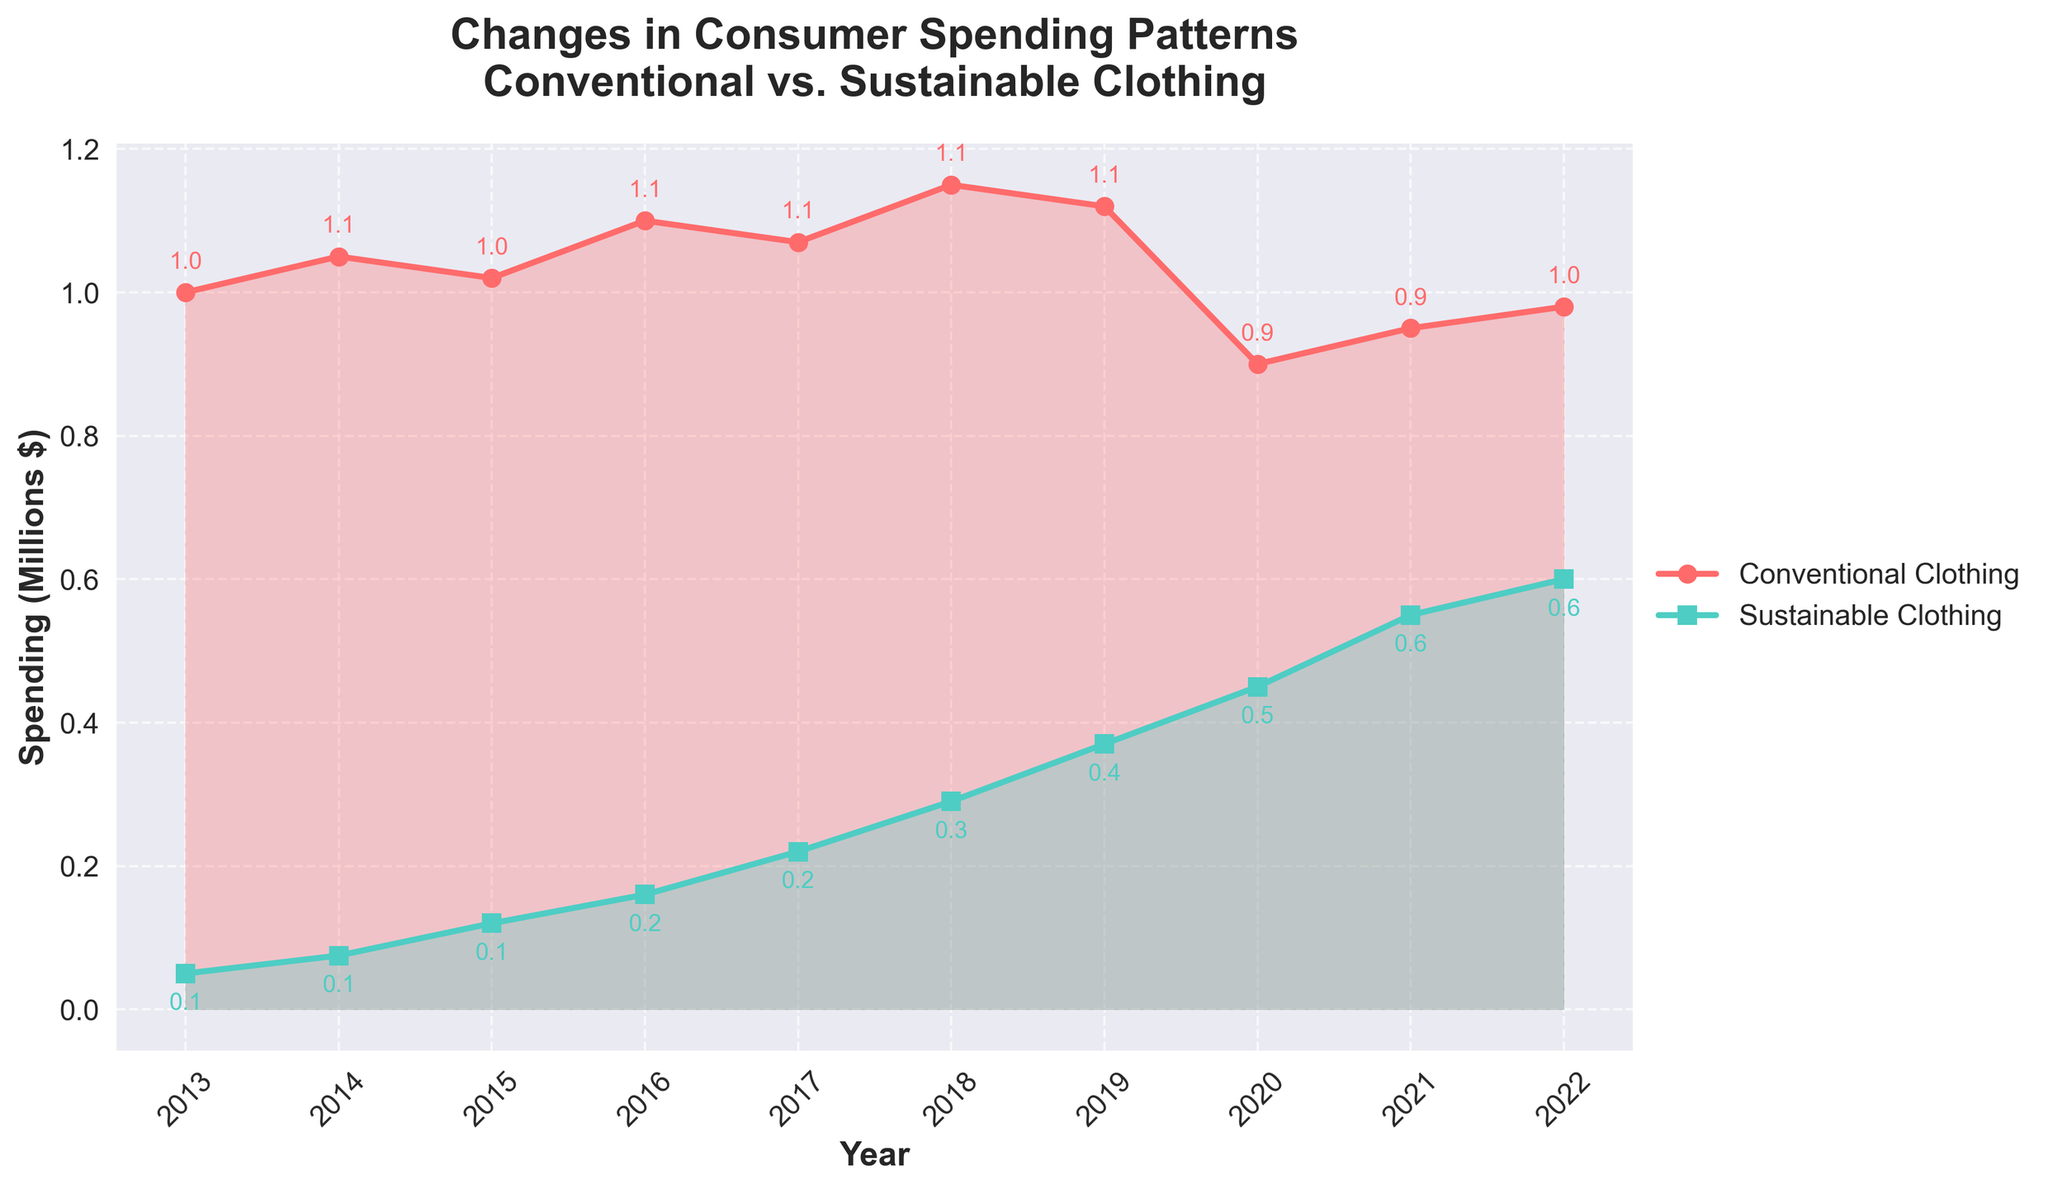What is the title of the figure? The title of the figure is displayed at the top. It reads "Changes in Consumer Spending Patterns\nConventional vs. Sustainable Clothing".
Answer: Changes in Consumer Spending Patterns\nConventional vs. Sustainable Clothing What are the spending values for conventional clothing and sustainable clothing in 2013? The plot marks spending values for each year. In 2013, the conventional clothing spending is represented by a red circle at 1.0 million dollars, and the sustainable clothing spending is shown by a green square at 0.05 million dollars.
Answer: $1,000,000 and $50,000 How did the spending on conventional clothing change from 2019 to 2020? The spending on conventional clothing in 2019 is around 1.12 million dollars, and in 2020 it drops to 0.9 million dollars. The change is a decrease of 0.22 million dollars.
Answer: Decreased by $220,000 Compare the spending on conventional clothing and sustainable clothing in 2022. In 2022, the plot shows approximately 0.98 million dollars on conventional clothing (red line) and 0.6 million dollars on sustainable clothing (green line).
Answer: Conventional: $980,000, Sustainable: $600,000 What is the total consumer spending on sustainable clothing between 2020 and 2022? To find the total, add the spending values for 2020 (0.45 million dollars), 2021 (0.55 million dollars), and 2022 (0.6 million dollars). This results in a total of 1.6 million dollars.
Answer: $1,600,000 Which year shows the highest spending on conventional clothing and what value is it? The plot shows the highest point in the time series for conventional clothing spend is in 2018 at approximately 1.15 million dollars.
Answer: 2018, $1,150,000 Did sustainable clothing spending ever exceed conventional clothing spending over the last 10 years? Observing the plot, there is no point where the green line (sustainable) exceeds the red line (conventional).
Answer: No Which year experienced the greatest increase in sustainable clothing spending compared to the previous year, and what was the amount of the increase? The largest increase is observed from 2016 to 2017, where spending went from 0.16 million dollars to 0.22 million dollars, showing an increase of 0.06 million dollars.
Answer: 2017, $60,000 What can we infer about consumer trends from 2020 to 2022 with regard to conventional vs. sustainable clothing? From the plot, we can see conventional clothing spending declined sharply in 2020 while sustainable clothing spending increased, indicating a shift in consumer preference towards sustainable clothing despite a partial recovery in conventional clothing spending later.
Answer: Shift towards sustainable clothing 